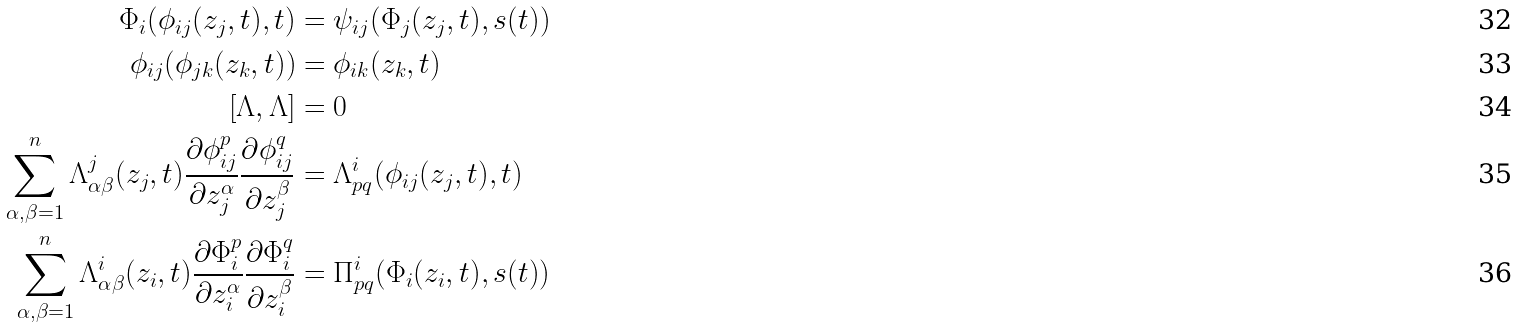<formula> <loc_0><loc_0><loc_500><loc_500>\Phi _ { i } ( \phi _ { i j } ( z _ { j } , t ) , t ) & = \psi _ { i j } ( \Phi _ { j } ( z _ { j } , t ) , s ( t ) ) \\ \phi _ { i j } ( \phi _ { j k } ( z _ { k } , t ) ) & = \phi _ { i k } ( z _ { k } , t ) \\ [ \Lambda , \Lambda ] & = 0 \\ \sum _ { \alpha , \beta = 1 } ^ { n } \Lambda _ { \alpha \beta } ^ { j } ( z _ { j } , t ) \frac { \partial \phi _ { i j } ^ { p } } { \partial z _ { j } ^ { \alpha } } \frac { \partial \phi _ { i j } ^ { q } } { \partial z _ { j } ^ { \beta } } & = \Lambda _ { p q } ^ { i } ( \phi _ { i j } ( z _ { j } , t ) , t ) \\ \sum _ { \alpha , \beta = 1 } ^ { n } \Lambda _ { \alpha \beta } ^ { i } ( z _ { i } , t ) \frac { \partial \Phi _ { i } ^ { p } } { \partial z _ { i } ^ { \alpha } } \frac { \partial \Phi _ { i } ^ { q } } { \partial z _ { i } ^ { \beta } } & = \Pi _ { p q } ^ { i } ( \Phi _ { i } ( z _ { i } , t ) , s ( t ) )</formula> 